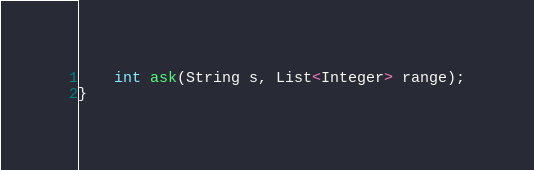<code> <loc_0><loc_0><loc_500><loc_500><_Java_>
    int ask(String s, List<Integer> range);
}
</code> 